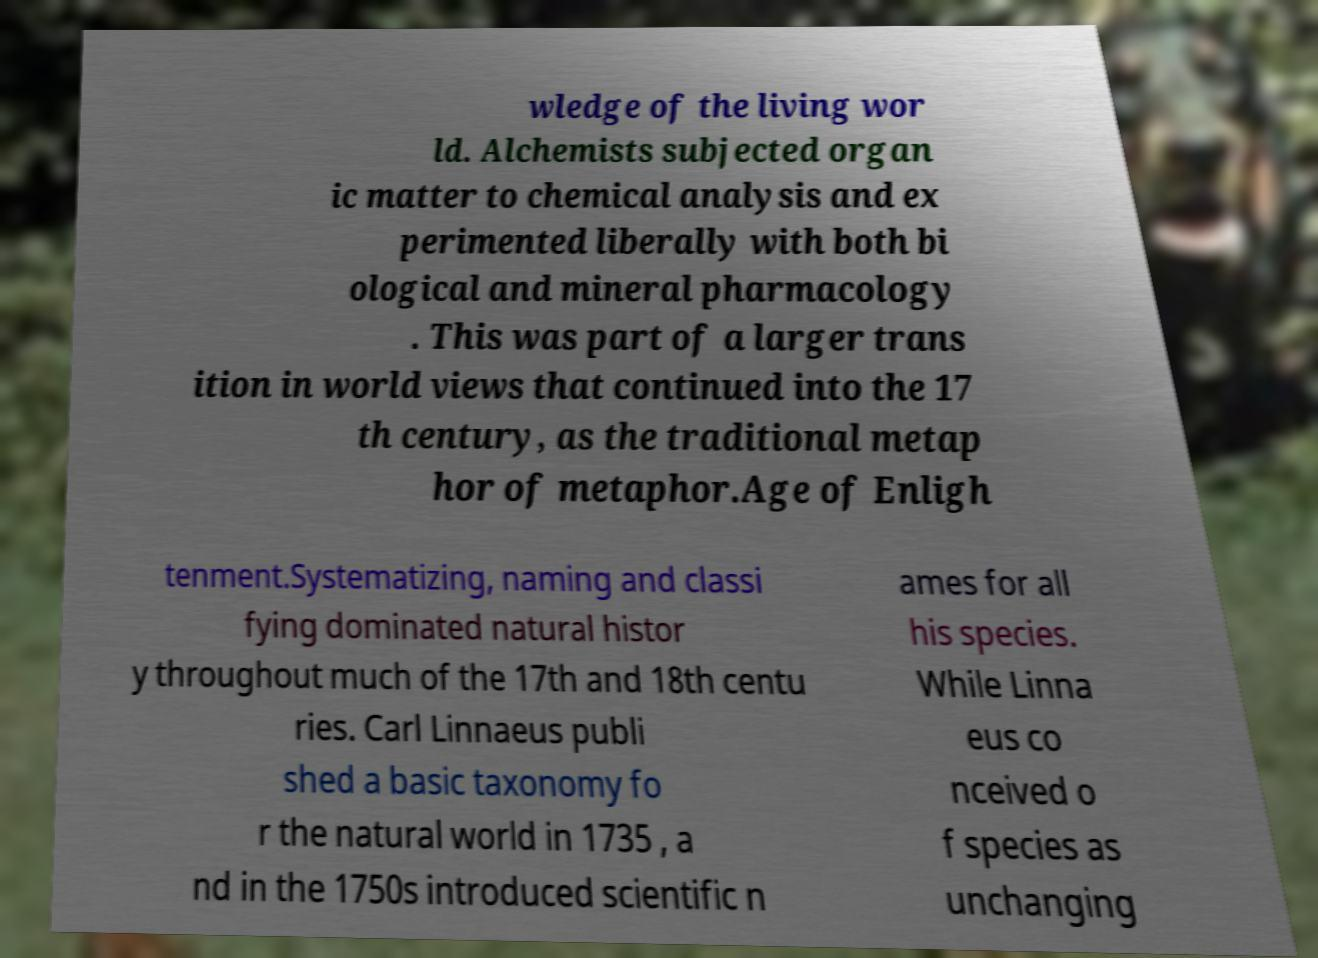Can you accurately transcribe the text from the provided image for me? wledge of the living wor ld. Alchemists subjected organ ic matter to chemical analysis and ex perimented liberally with both bi ological and mineral pharmacology . This was part of a larger trans ition in world views that continued into the 17 th century, as the traditional metap hor of metaphor.Age of Enligh tenment.Systematizing, naming and classi fying dominated natural histor y throughout much of the 17th and 18th centu ries. Carl Linnaeus publi shed a basic taxonomy fo r the natural world in 1735 , a nd in the 1750s introduced scientific n ames for all his species. While Linna eus co nceived o f species as unchanging 